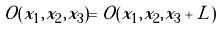<formula> <loc_0><loc_0><loc_500><loc_500>O ( x _ { 1 } , x _ { 2 } , x _ { 3 } ) = O ( x _ { 1 } , x _ { 2 } , x _ { 3 } + L )</formula> 